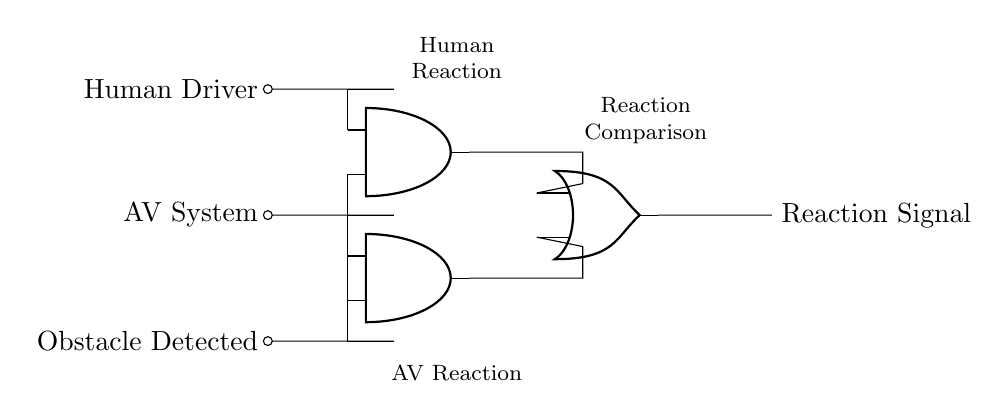What are the input signals to the circuit? The circuit has three input signals labeled as Human Driver, AV System, and Obstacle Detected. These are the components that provide the necessary information for the AND gates to process.
Answer: Human Driver, AV System, Obstacle Detected How many AND gates are present in the circuit? The diagram shows two AND gates used to compare the reaction times of the human driver and the AV system to the obstacle detected. This is determined by counting the AND gate symbols in the diagram.
Answer: 2 What is the output of the circuit? The output of the circuit is labeled as Reaction Signal, which represents the result of the logical operations performed by the AND and OR gates in response to the inputs provided.
Answer: Reaction Signal What do the AND gates compare? The first AND gate compares the Human Driver input and the Obstacle Detected input, while the second AND gate compares the AV System input and the Obstacle Detected input. This shows how both the human reaction and the AV response are evaluated when an obstacle is identified.
Answer: Human Driver and Obstacle Detected; AV System and Obstacle Detected What type of logic gate is used to combine the outputs of the AND gates? The circuit uses an OR gate to combine the outputs from the two AND gates. This means any positive reaction from either the human or AV system in response to the obstacle would trigger the Reaction Signal output.
Answer: OR gate How does the presence of "Obstacle Detected" affect the output? The Obstacle Detected input is critical since both AND gates require this input to produce an output. If this signal is not active (in the logic circuit context, low), then neither AND gate will output a positive signal to the OR gate, affecting the overall Reaction Signal.
Answer: It activates the AND gates 